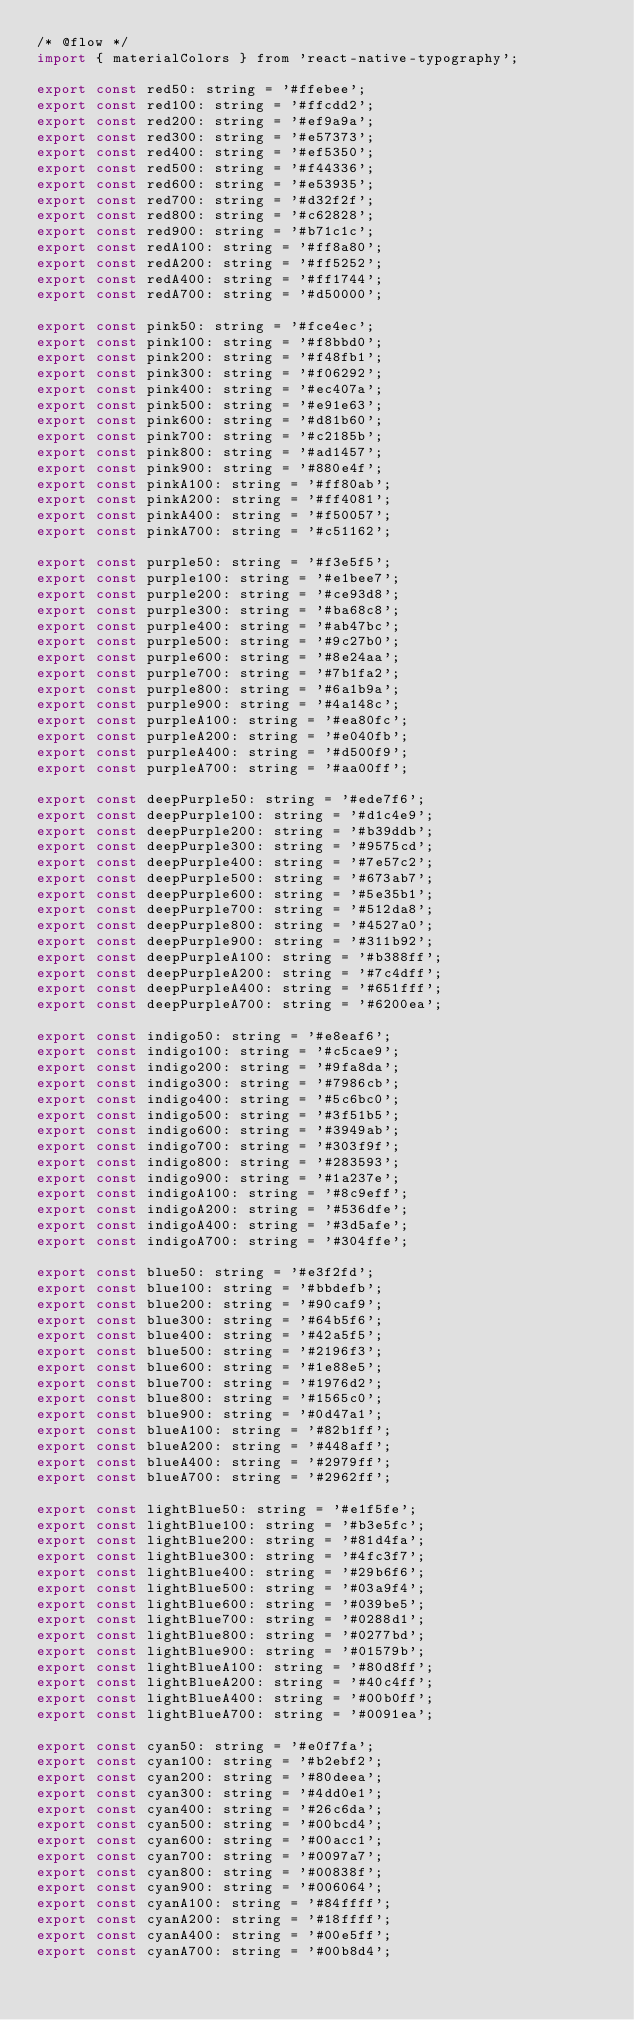<code> <loc_0><loc_0><loc_500><loc_500><_JavaScript_>/* @flow */
import { materialColors } from 'react-native-typography';

export const red50: string = '#ffebee';
export const red100: string = '#ffcdd2';
export const red200: string = '#ef9a9a';
export const red300: string = '#e57373';
export const red400: string = '#ef5350';
export const red500: string = '#f44336';
export const red600: string = '#e53935';
export const red700: string = '#d32f2f';
export const red800: string = '#c62828';
export const red900: string = '#b71c1c';
export const redA100: string = '#ff8a80';
export const redA200: string = '#ff5252';
export const redA400: string = '#ff1744';
export const redA700: string = '#d50000';

export const pink50: string = '#fce4ec';
export const pink100: string = '#f8bbd0';
export const pink200: string = '#f48fb1';
export const pink300: string = '#f06292';
export const pink400: string = '#ec407a';
export const pink500: string = '#e91e63';
export const pink600: string = '#d81b60';
export const pink700: string = '#c2185b';
export const pink800: string = '#ad1457';
export const pink900: string = '#880e4f';
export const pinkA100: string = '#ff80ab';
export const pinkA200: string = '#ff4081';
export const pinkA400: string = '#f50057';
export const pinkA700: string = '#c51162';

export const purple50: string = '#f3e5f5';
export const purple100: string = '#e1bee7';
export const purple200: string = '#ce93d8';
export const purple300: string = '#ba68c8';
export const purple400: string = '#ab47bc';
export const purple500: string = '#9c27b0';
export const purple600: string = '#8e24aa';
export const purple700: string = '#7b1fa2';
export const purple800: string = '#6a1b9a';
export const purple900: string = '#4a148c';
export const purpleA100: string = '#ea80fc';
export const purpleA200: string = '#e040fb';
export const purpleA400: string = '#d500f9';
export const purpleA700: string = '#aa00ff';

export const deepPurple50: string = '#ede7f6';
export const deepPurple100: string = '#d1c4e9';
export const deepPurple200: string = '#b39ddb';
export const deepPurple300: string = '#9575cd';
export const deepPurple400: string = '#7e57c2';
export const deepPurple500: string = '#673ab7';
export const deepPurple600: string = '#5e35b1';
export const deepPurple700: string = '#512da8';
export const deepPurple800: string = '#4527a0';
export const deepPurple900: string = '#311b92';
export const deepPurpleA100: string = '#b388ff';
export const deepPurpleA200: string = '#7c4dff';
export const deepPurpleA400: string = '#651fff';
export const deepPurpleA700: string = '#6200ea';

export const indigo50: string = '#e8eaf6';
export const indigo100: string = '#c5cae9';
export const indigo200: string = '#9fa8da';
export const indigo300: string = '#7986cb';
export const indigo400: string = '#5c6bc0';
export const indigo500: string = '#3f51b5';
export const indigo600: string = '#3949ab';
export const indigo700: string = '#303f9f';
export const indigo800: string = '#283593';
export const indigo900: string = '#1a237e';
export const indigoA100: string = '#8c9eff';
export const indigoA200: string = '#536dfe';
export const indigoA400: string = '#3d5afe';
export const indigoA700: string = '#304ffe';

export const blue50: string = '#e3f2fd';
export const blue100: string = '#bbdefb';
export const blue200: string = '#90caf9';
export const blue300: string = '#64b5f6';
export const blue400: string = '#42a5f5';
export const blue500: string = '#2196f3';
export const blue600: string = '#1e88e5';
export const blue700: string = '#1976d2';
export const blue800: string = '#1565c0';
export const blue900: string = '#0d47a1';
export const blueA100: string = '#82b1ff';
export const blueA200: string = '#448aff';
export const blueA400: string = '#2979ff';
export const blueA700: string = '#2962ff';

export const lightBlue50: string = '#e1f5fe';
export const lightBlue100: string = '#b3e5fc';
export const lightBlue200: string = '#81d4fa';
export const lightBlue300: string = '#4fc3f7';
export const lightBlue400: string = '#29b6f6';
export const lightBlue500: string = '#03a9f4';
export const lightBlue600: string = '#039be5';
export const lightBlue700: string = '#0288d1';
export const lightBlue800: string = '#0277bd';
export const lightBlue900: string = '#01579b';
export const lightBlueA100: string = '#80d8ff';
export const lightBlueA200: string = '#40c4ff';
export const lightBlueA400: string = '#00b0ff';
export const lightBlueA700: string = '#0091ea';

export const cyan50: string = '#e0f7fa';
export const cyan100: string = '#b2ebf2';
export const cyan200: string = '#80deea';
export const cyan300: string = '#4dd0e1';
export const cyan400: string = '#26c6da';
export const cyan500: string = '#00bcd4';
export const cyan600: string = '#00acc1';
export const cyan700: string = '#0097a7';
export const cyan800: string = '#00838f';
export const cyan900: string = '#006064';
export const cyanA100: string = '#84ffff';
export const cyanA200: string = '#18ffff';
export const cyanA400: string = '#00e5ff';
export const cyanA700: string = '#00b8d4';
</code> 